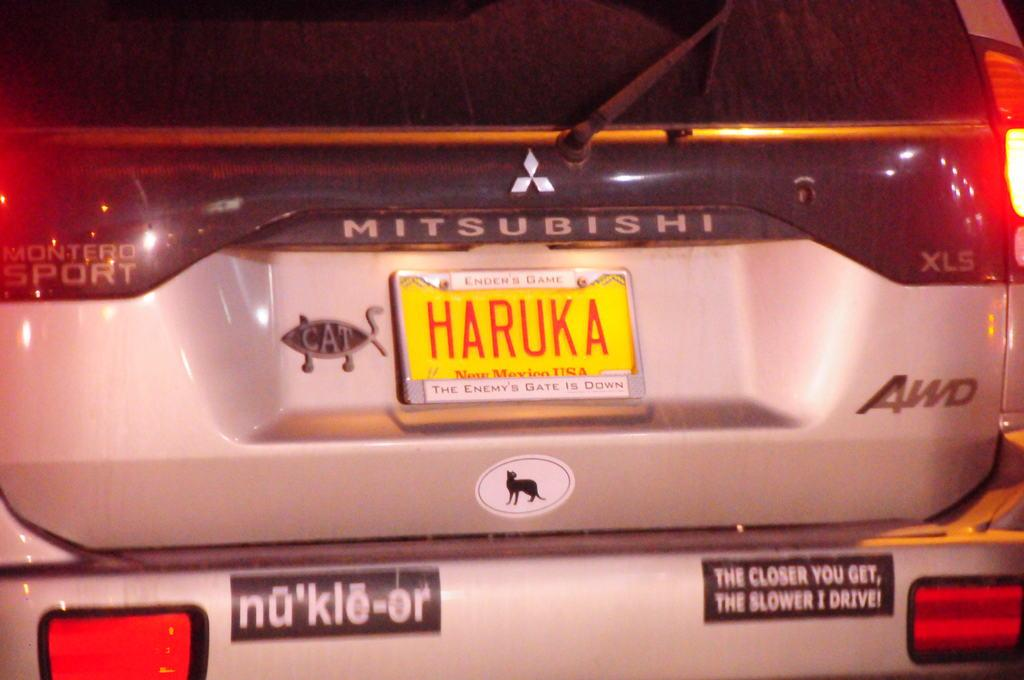What part of a car is visible in the image? The image shows the backside part of a car. What can be found on the car to identify it? There is a number plate visible on the car. What type of knife is being used to cut the cherry on the car's trunk? There is no knife or cherry present in the image; it only shows the backside part of a car with a visible number plate. 